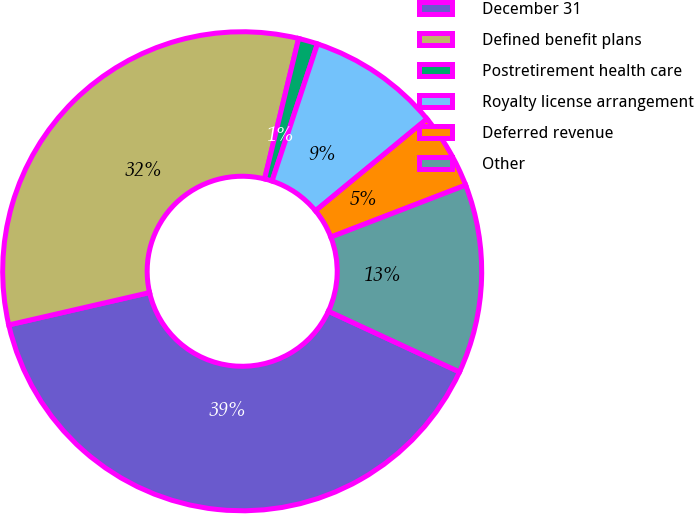Convert chart to OTSL. <chart><loc_0><loc_0><loc_500><loc_500><pie_chart><fcel>December 31<fcel>Defined benefit plans<fcel>Postretirement health care<fcel>Royalty license arrangement<fcel>Deferred revenue<fcel>Other<nl><fcel>39.5%<fcel>32.39%<fcel>1.3%<fcel>8.94%<fcel>5.12%<fcel>12.76%<nl></chart> 